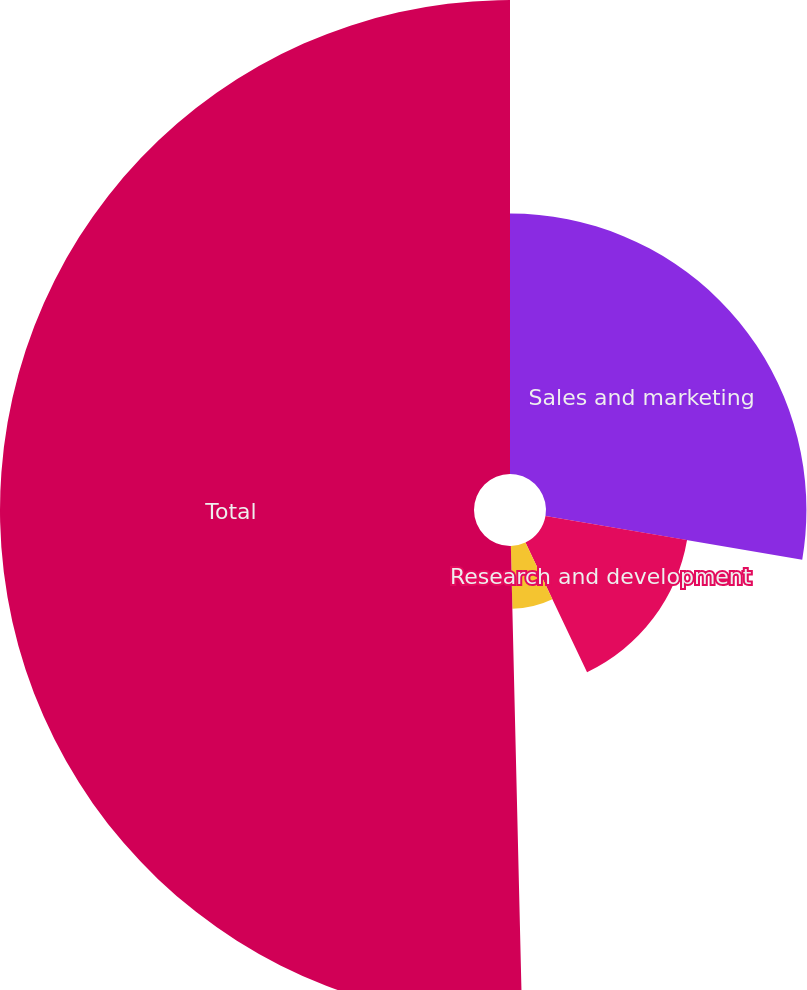<chart> <loc_0><loc_0><loc_500><loc_500><pie_chart><fcel>Sales and marketing<fcel>Research and development<fcel>General and administrative<fcel>Total<nl><fcel>27.68%<fcel>15.26%<fcel>6.68%<fcel>50.38%<nl></chart> 